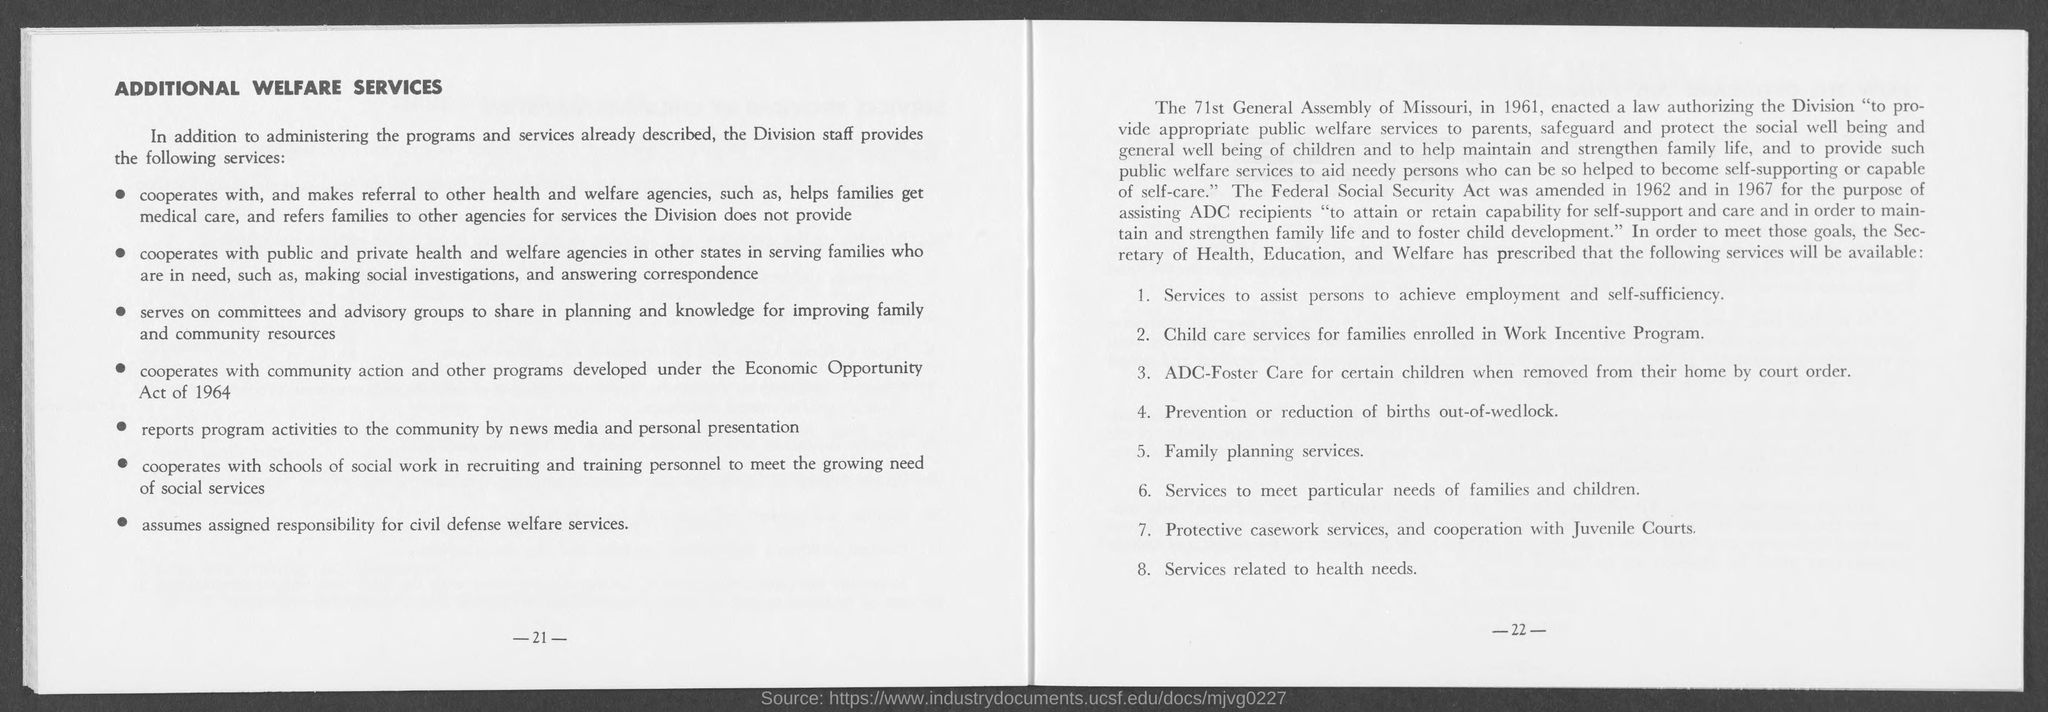List a handful of essential elements in this visual. The page number at the bottom of the right page is -22-. The title at the top of the left page is 'Additional Welfare Services.' The number at the bottom of the left page is 21. 